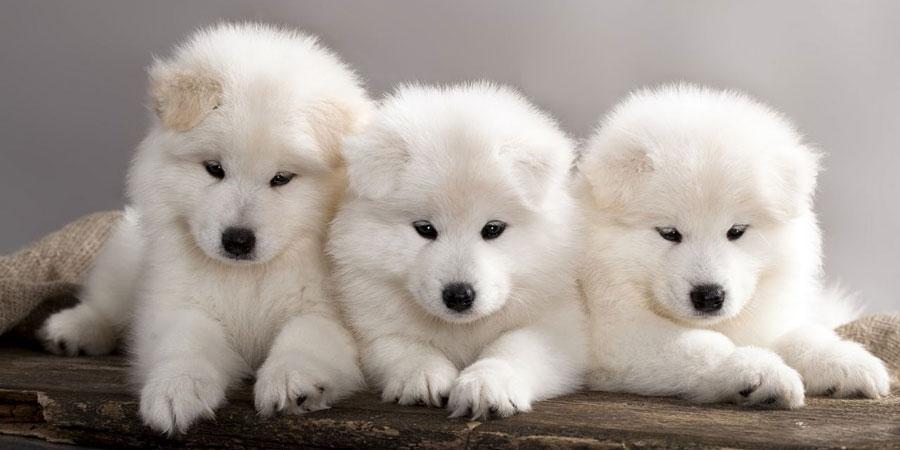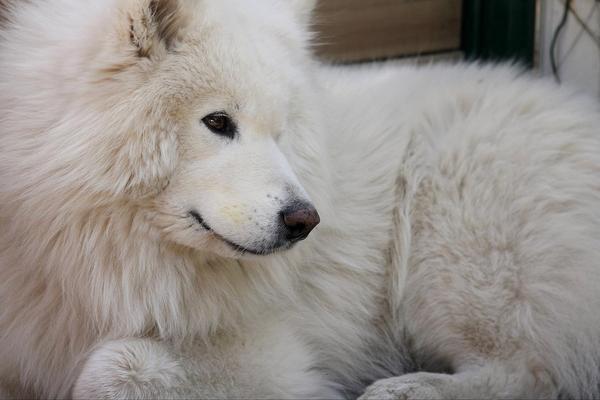The first image is the image on the left, the second image is the image on the right. Given the left and right images, does the statement "All four dogs are white." hold true? Answer yes or no. Yes. The first image is the image on the left, the second image is the image on the right. Examine the images to the left and right. Is the description "One image shows three same-sized white puppies posed side-by-side." accurate? Answer yes or no. Yes. 